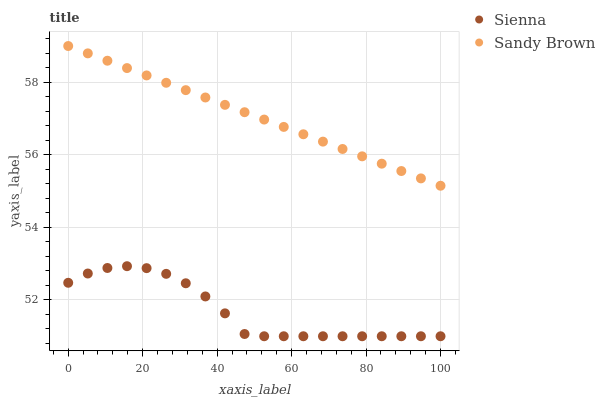Does Sienna have the minimum area under the curve?
Answer yes or no. Yes. Does Sandy Brown have the maximum area under the curve?
Answer yes or no. Yes. Does Sandy Brown have the minimum area under the curve?
Answer yes or no. No. Is Sandy Brown the smoothest?
Answer yes or no. Yes. Is Sienna the roughest?
Answer yes or no. Yes. Is Sandy Brown the roughest?
Answer yes or no. No. Does Sienna have the lowest value?
Answer yes or no. Yes. Does Sandy Brown have the lowest value?
Answer yes or no. No. Does Sandy Brown have the highest value?
Answer yes or no. Yes. Is Sienna less than Sandy Brown?
Answer yes or no. Yes. Is Sandy Brown greater than Sienna?
Answer yes or no. Yes. Does Sienna intersect Sandy Brown?
Answer yes or no. No. 